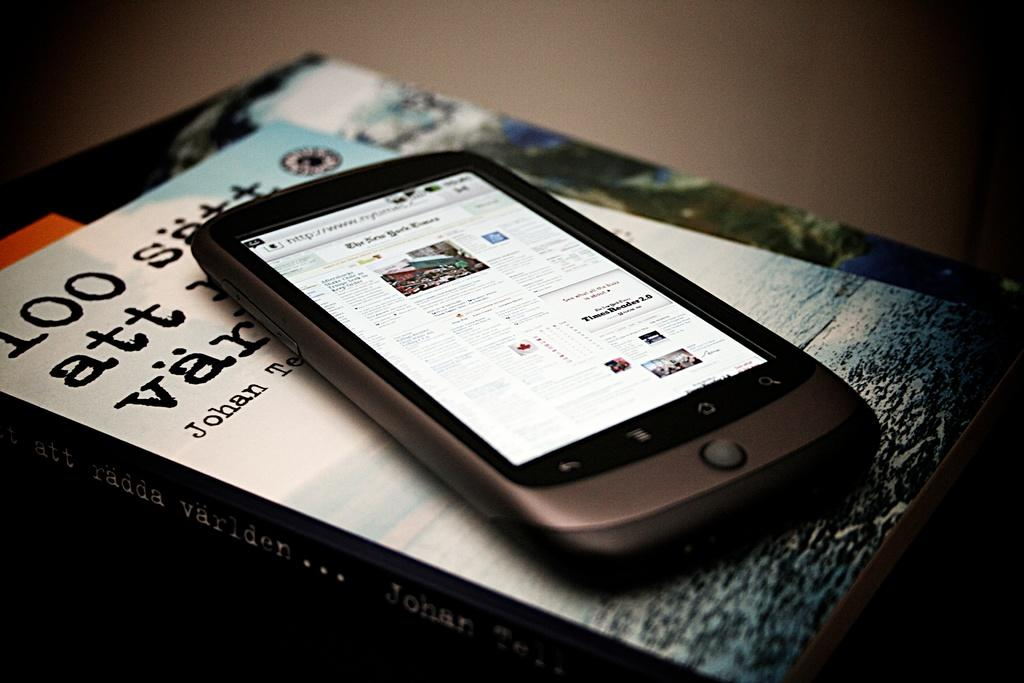<image>
Offer a succinct explanation of the picture presented. A cell phone sits on top of a book by Johan Tell called 100 satt att radda varlden 